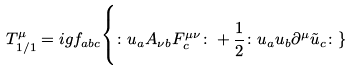Convert formula to latex. <formula><loc_0><loc_0><loc_500><loc_500>T ^ { \mu } _ { 1 / 1 } = i g f _ { a b c } \Big \{ \colon u _ { a } A _ { \nu b } F ^ { \mu \nu } _ { c } \colon + \frac { 1 } { 2 } \colon u _ { a } u _ { b } \partial ^ { \mu } \tilde { u } _ { c } \colon \}</formula> 